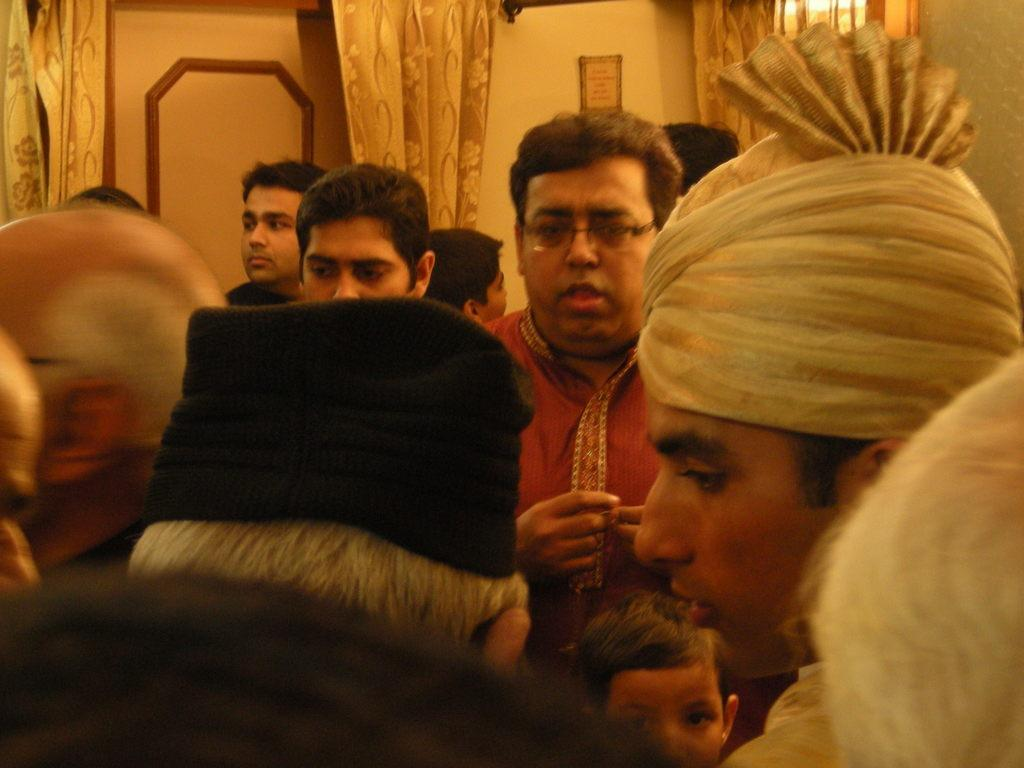How many people are in the image? There is a group of people in the image, but the exact number cannot be determined from the provided facts. What can be seen in the background of the image? There are curtains and a frame on the wall in the background of the image. What type of clover is being used as a decoration on the frame in the image? There is no clover present in the image, and therefore no such decoration can be observed. 